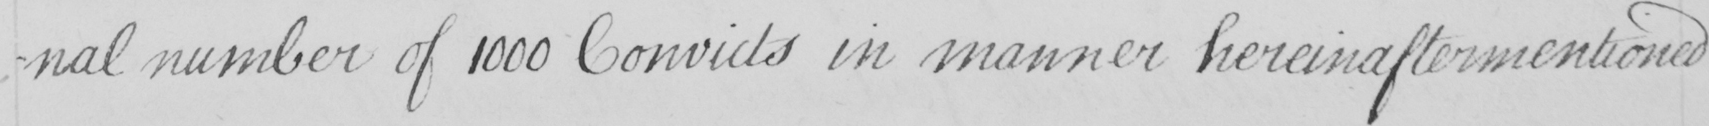Can you tell me what this handwritten text says? -nal number of 1000 Convicts in manner hereinaftermentioned 